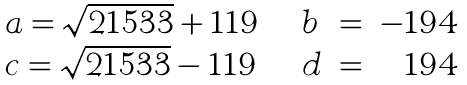Convert formula to latex. <formula><loc_0><loc_0><loc_500><loc_500>\begin{array} { l l l l r } { { a = \sqrt { 2 1 5 3 3 } + 1 1 9 \, } } & { \, } & { b } & { = } & { - 1 9 4 } \\ { { c = \sqrt { 2 1 5 3 3 } - 1 1 9 \, } } & { \, } & { d } & { = } & { 1 9 4 } \end{array}</formula> 